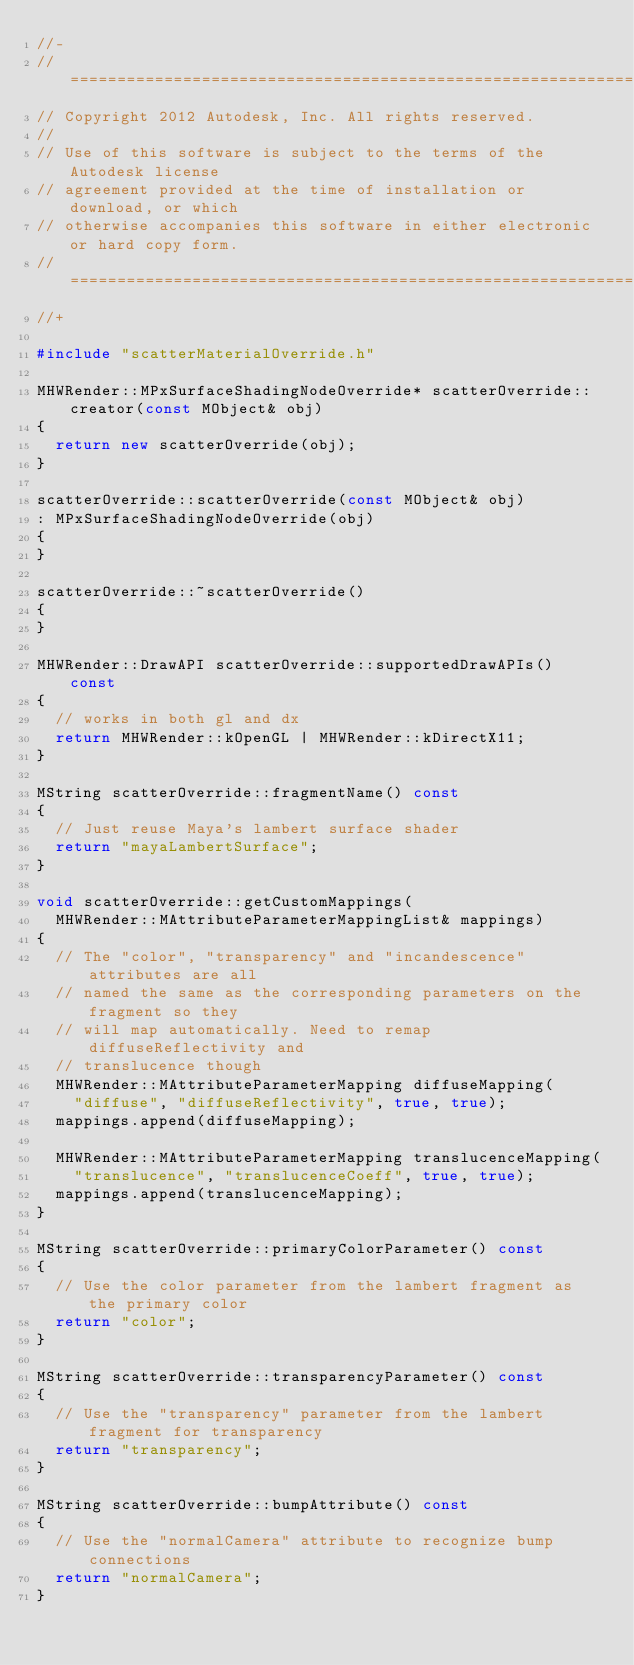Convert code to text. <code><loc_0><loc_0><loc_500><loc_500><_C++_>//-
// ===========================================================================
// Copyright 2012 Autodesk, Inc. All rights reserved.
//
// Use of this software is subject to the terms of the Autodesk license
// agreement provided at the time of installation or download, or which
// otherwise accompanies this software in either electronic or hard copy form.
// ===========================================================================
//+

#include "scatterMaterialOverride.h"

MHWRender::MPxSurfaceShadingNodeOverride* scatterOverride::creator(const MObject& obj)
{
	return new scatterOverride(obj);
}

scatterOverride::scatterOverride(const MObject& obj)
: MPxSurfaceShadingNodeOverride(obj)
{
}

scatterOverride::~scatterOverride()
{
}

MHWRender::DrawAPI scatterOverride::supportedDrawAPIs() const
{
	// works in both gl and dx
	return MHWRender::kOpenGL | MHWRender::kDirectX11;
}

MString scatterOverride::fragmentName() const
{
	// Just reuse Maya's lambert surface shader
	return "mayaLambertSurface";
}

void scatterOverride::getCustomMappings(
	MHWRender::MAttributeParameterMappingList& mappings)
{
	// The "color", "transparency" and "incandescence" attributes are all
	// named the same as the corresponding parameters on the fragment so they
	// will map automatically. Need to remap diffuseReflectivity and
	// translucence though
	MHWRender::MAttributeParameterMapping diffuseMapping(
		"diffuse", "diffuseReflectivity", true, true);
	mappings.append(diffuseMapping);

	MHWRender::MAttributeParameterMapping translucenceMapping(
		"translucence", "translucenceCoeff", true, true);
	mappings.append(translucenceMapping);
}

MString scatterOverride::primaryColorParameter() const
{
	// Use the color parameter from the lambert fragment as the primary color
	return "color";
}

MString scatterOverride::transparencyParameter() const
{
	// Use the "transparency" parameter from the lambert fragment for transparency
	return "transparency";
}

MString scatterOverride::bumpAttribute() const
{
	// Use the "normalCamera" attribute to recognize bump connections
	return "normalCamera";
}
</code> 